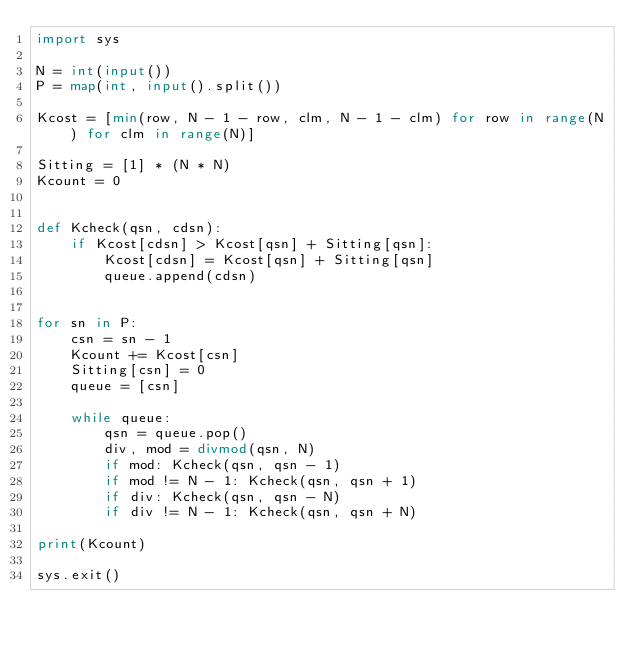Convert code to text. <code><loc_0><loc_0><loc_500><loc_500><_Python_>import sys

N = int(input())
P = map(int, input().split())

Kcost = [min(row, N - 1 - row, clm, N - 1 - clm) for row in range(N) for clm in range(N)]

Sitting = [1] * (N * N)
Kcount = 0


def Kcheck(qsn, cdsn):
    if Kcost[cdsn] > Kcost[qsn] + Sitting[qsn]:
        Kcost[cdsn] = Kcost[qsn] + Sitting[qsn]
        queue.append(cdsn)


for sn in P:
    csn = sn - 1
    Kcount += Kcost[csn]
    Sitting[csn] = 0
    queue = [csn]

    while queue:
        qsn = queue.pop()
        div, mod = divmod(qsn, N)
        if mod: Kcheck(qsn, qsn - 1)
        if mod != N - 1: Kcheck(qsn, qsn + 1)
        if div: Kcheck(qsn, qsn - N)
        if div != N - 1: Kcheck(qsn, qsn + N)

print(Kcount)

sys.exit()
</code> 